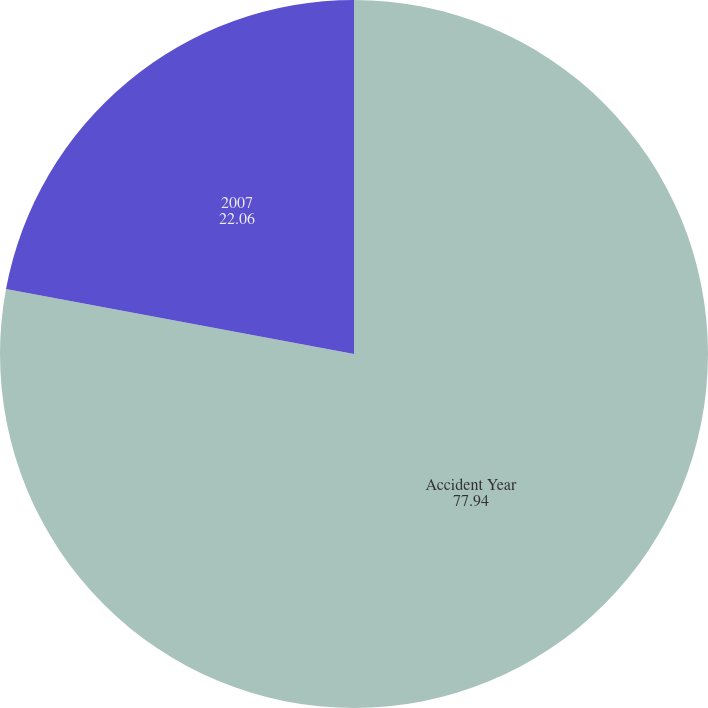<chart> <loc_0><loc_0><loc_500><loc_500><pie_chart><fcel>Accident Year<fcel>2007<nl><fcel>77.94%<fcel>22.06%<nl></chart> 